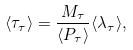<formula> <loc_0><loc_0><loc_500><loc_500>\langle \tau _ { \tau } \rangle = \frac { M _ { \tau } } { \langle P _ { \tau } \rangle } \langle \lambda _ { \tau } \rangle ,</formula> 